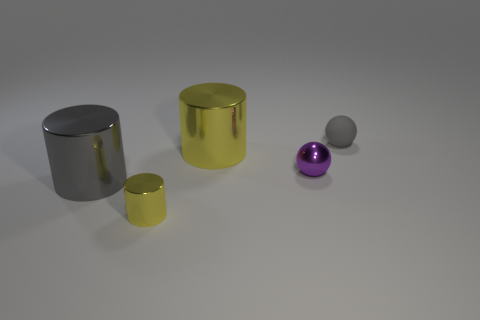There is a sphere that is in front of the rubber thing; is it the same color as the metallic object that is behind the tiny purple metal thing?
Your answer should be very brief. No. What is the shape of the purple metal thing?
Your answer should be very brief. Sphere. How many purple metallic spheres are in front of the small gray thing?
Keep it short and to the point. 1. What number of small cylinders are made of the same material as the big gray cylinder?
Offer a terse response. 1. Do the sphere that is to the left of the gray matte ball and the tiny gray thing have the same material?
Offer a very short reply. No. Are any metallic things visible?
Offer a terse response. Yes. There is a thing that is behind the tiny purple object and left of the rubber sphere; how big is it?
Your response must be concise. Large. Are there more gray matte spheres on the right side of the matte sphere than tiny yellow cylinders that are right of the tiny yellow thing?
Give a very brief answer. No. There is a metal cylinder that is the same color as the tiny rubber thing; what size is it?
Your response must be concise. Large. What color is the small shiny sphere?
Provide a succinct answer. Purple. 